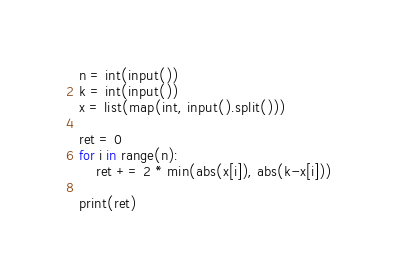Convert code to text. <code><loc_0><loc_0><loc_500><loc_500><_Python_>n = int(input())
k = int(input())
x = list(map(int, input().split()))

ret = 0
for i in range(n):
    ret += 2 * min(abs(x[i]), abs(k-x[i]))

print(ret)
</code> 